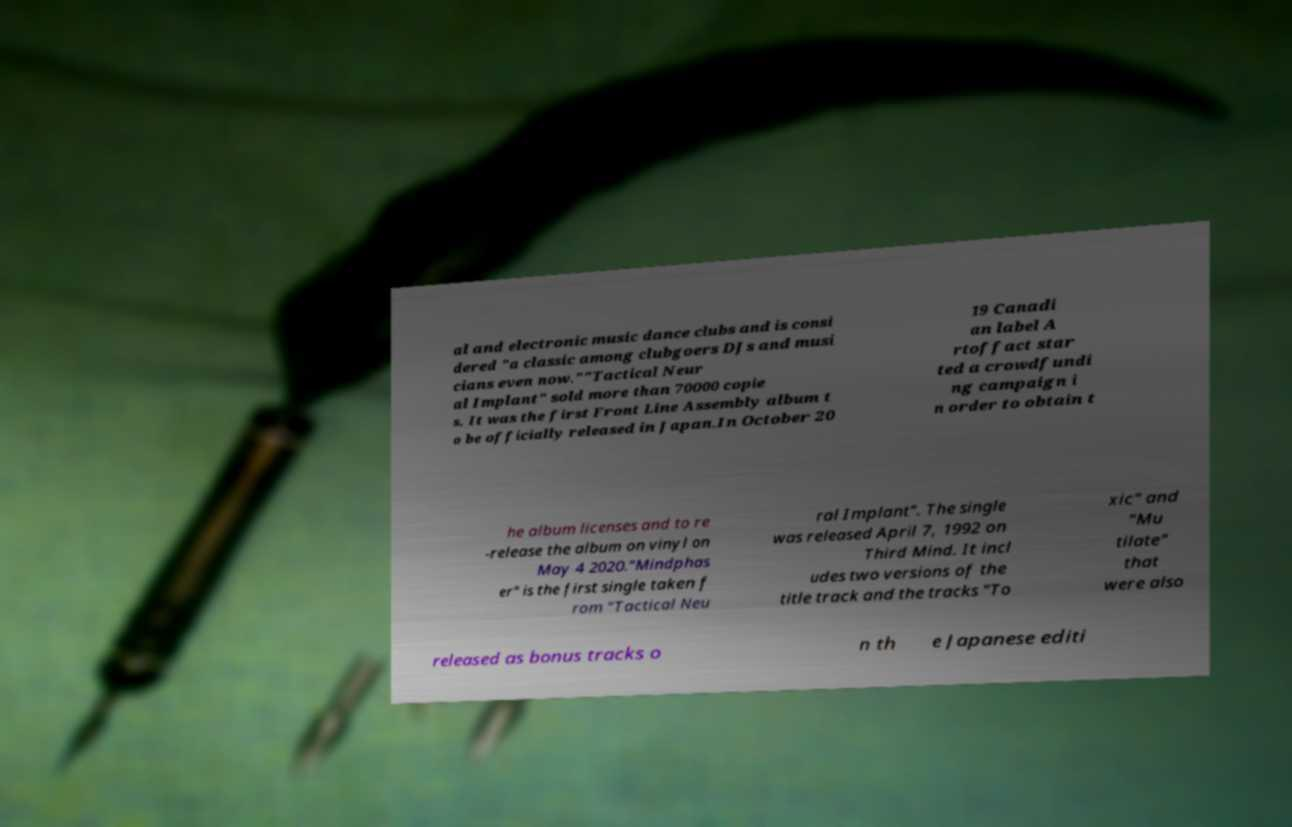Please identify and transcribe the text found in this image. al and electronic music dance clubs and is consi dered "a classic among clubgoers DJs and musi cians even now.""Tactical Neur al Implant" sold more than 70000 copie s. It was the first Front Line Assembly album t o be officially released in Japan.In October 20 19 Canadi an label A rtoffact star ted a crowdfundi ng campaign i n order to obtain t he album licenses and to re -release the album on vinyl on May 4 2020."Mindphas er" is the first single taken f rom "Tactical Neu ral Implant". The single was released April 7, 1992 on Third Mind. It incl udes two versions of the title track and the tracks "To xic" and "Mu tilate" that were also released as bonus tracks o n th e Japanese editi 